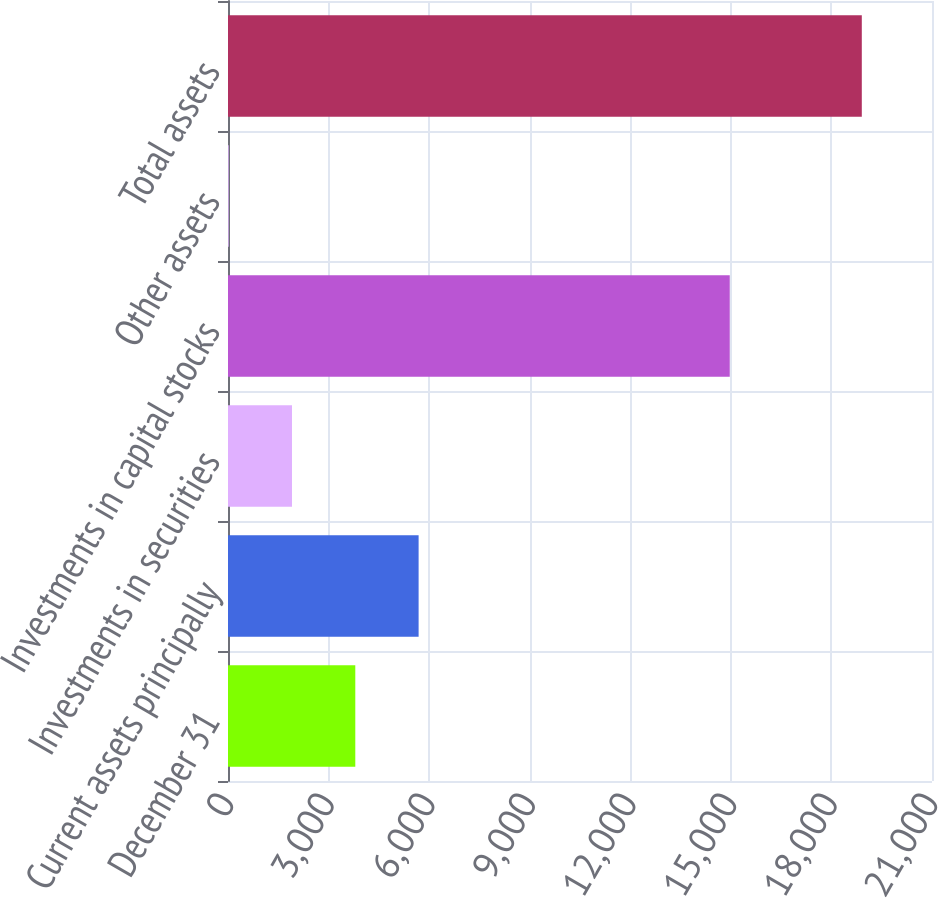<chart> <loc_0><loc_0><loc_500><loc_500><bar_chart><fcel>December 31<fcel>Current assets principally<fcel>Investments in securities<fcel>Investments in capital stocks<fcel>Other assets<fcel>Total assets<nl><fcel>3797.2<fcel>5685.8<fcel>1908.6<fcel>14967<fcel>20<fcel>18906<nl></chart> 